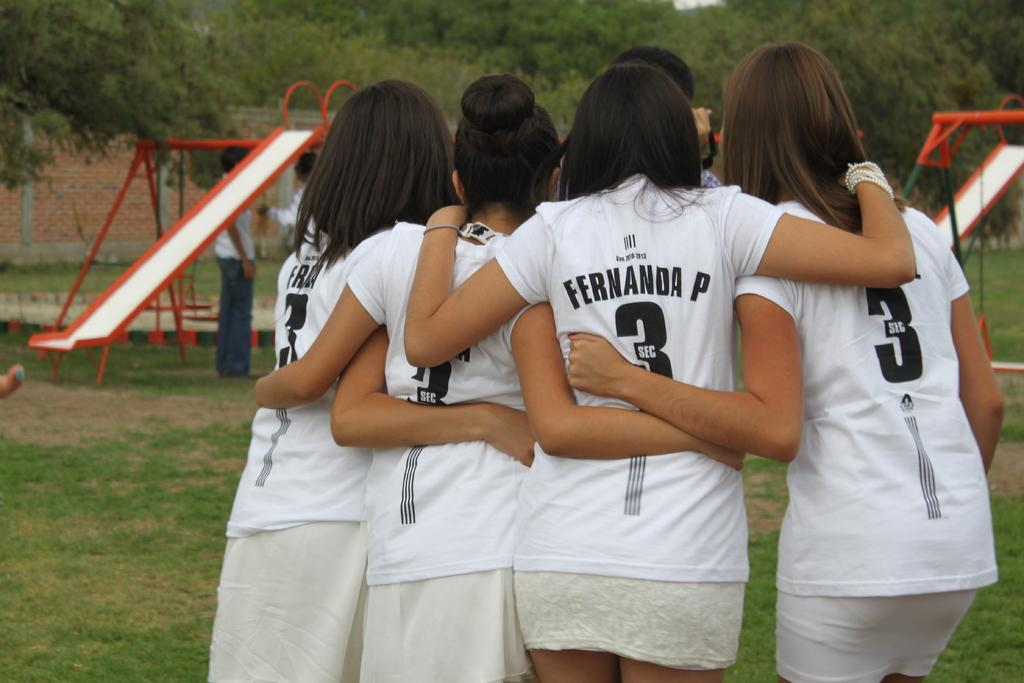<image>
Write a terse but informative summary of the picture. a few teammates and one with the number 3 on 